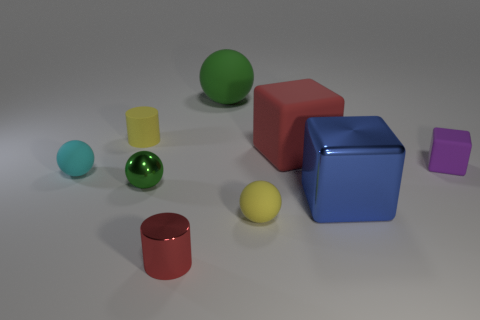Subtract all big blocks. How many blocks are left? 1 Subtract all red blocks. How many green balls are left? 2 Subtract all cyan spheres. How many spheres are left? 3 Subtract 1 cubes. How many cubes are left? 2 Subtract all gray cubes. Subtract all red cylinders. How many cubes are left? 3 Subtract all cylinders. How many objects are left? 7 Add 5 large spheres. How many large spheres exist? 6 Subtract 0 blue cylinders. How many objects are left? 9 Subtract all big purple matte cubes. Subtract all large blue blocks. How many objects are left? 8 Add 7 tiny green metallic objects. How many tiny green metallic objects are left? 8 